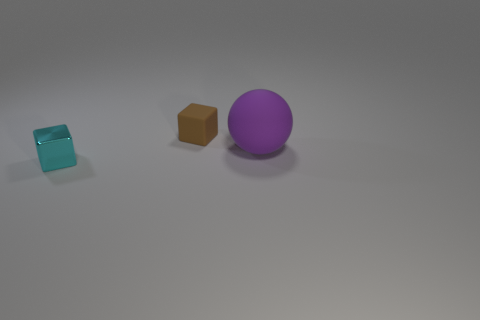There is a rubber thing to the left of the purple rubber thing; does it have the same color as the matte thing that is in front of the tiny brown cube?
Make the answer very short. No. There is another thing that is the same shape as the tiny cyan thing; what is its size?
Provide a short and direct response. Small. There is a cyan metal block; are there any small brown matte blocks behind it?
Ensure brevity in your answer.  Yes. Are there an equal number of cyan metallic blocks that are on the right side of the large purple rubber sphere and big cyan rubber cylinders?
Ensure brevity in your answer.  Yes. There is a tiny cube on the right side of the small cube to the left of the small matte cube; is there a thing that is on the right side of it?
Make the answer very short. Yes. What is the material of the small brown object?
Your answer should be compact. Rubber. How many other things are there of the same shape as the big purple rubber object?
Provide a short and direct response. 0. Is the shape of the cyan metal thing the same as the big matte object?
Your answer should be compact. No. How many objects are either tiny things that are behind the cyan metal object or things in front of the brown thing?
Provide a short and direct response. 3. How many objects are either small rubber blocks or balls?
Keep it short and to the point. 2. 